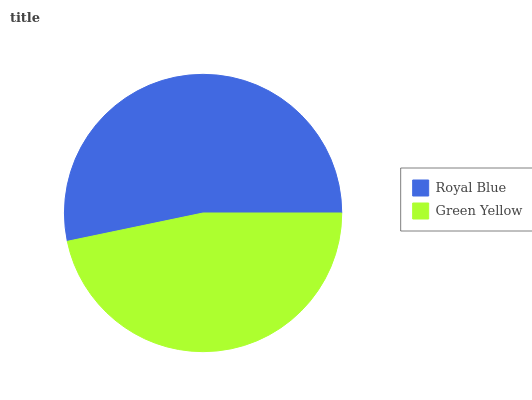Is Green Yellow the minimum?
Answer yes or no. Yes. Is Royal Blue the maximum?
Answer yes or no. Yes. Is Green Yellow the maximum?
Answer yes or no. No. Is Royal Blue greater than Green Yellow?
Answer yes or no. Yes. Is Green Yellow less than Royal Blue?
Answer yes or no. Yes. Is Green Yellow greater than Royal Blue?
Answer yes or no. No. Is Royal Blue less than Green Yellow?
Answer yes or no. No. Is Royal Blue the high median?
Answer yes or no. Yes. Is Green Yellow the low median?
Answer yes or no. Yes. Is Green Yellow the high median?
Answer yes or no. No. Is Royal Blue the low median?
Answer yes or no. No. 